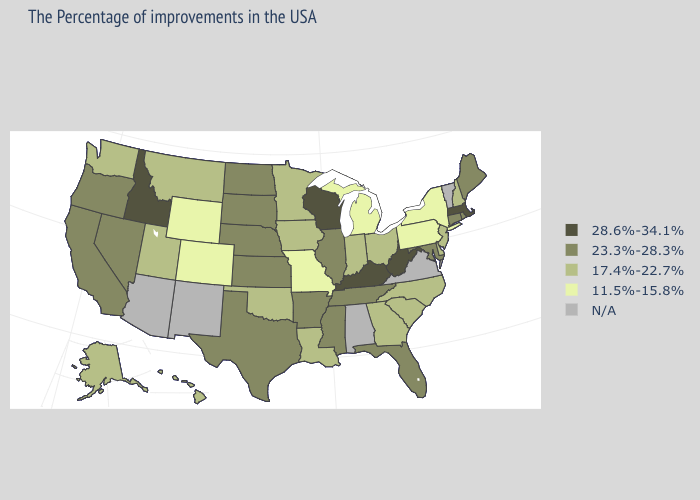What is the lowest value in states that border Ohio?
Give a very brief answer. 11.5%-15.8%. Name the states that have a value in the range N/A?
Concise answer only. Vermont, Virginia, Alabama, New Mexico, Arizona. What is the highest value in the West ?
Give a very brief answer. 28.6%-34.1%. Does the map have missing data?
Be succinct. Yes. Which states have the highest value in the USA?
Be succinct. Massachusetts, West Virginia, Kentucky, Wisconsin, Idaho. What is the value of Oregon?
Quick response, please. 23.3%-28.3%. Is the legend a continuous bar?
Write a very short answer. No. What is the value of Maine?
Give a very brief answer. 23.3%-28.3%. What is the highest value in states that border Indiana?
Concise answer only. 28.6%-34.1%. Among the states that border Oregon , does Washington have the highest value?
Keep it brief. No. Does Massachusetts have the highest value in the Northeast?
Quick response, please. Yes. How many symbols are there in the legend?
Answer briefly. 5. 